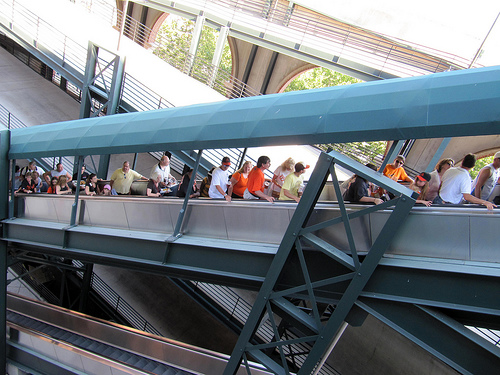<image>
Is the man one under the man two? Yes. The man one is positioned underneath the man two, with the man two above it in the vertical space. 